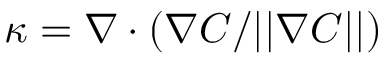Convert formula to latex. <formula><loc_0><loc_0><loc_500><loc_500>\kappa = \nabla \cdot ( \nabla C / | | \nabla C | | )</formula> 